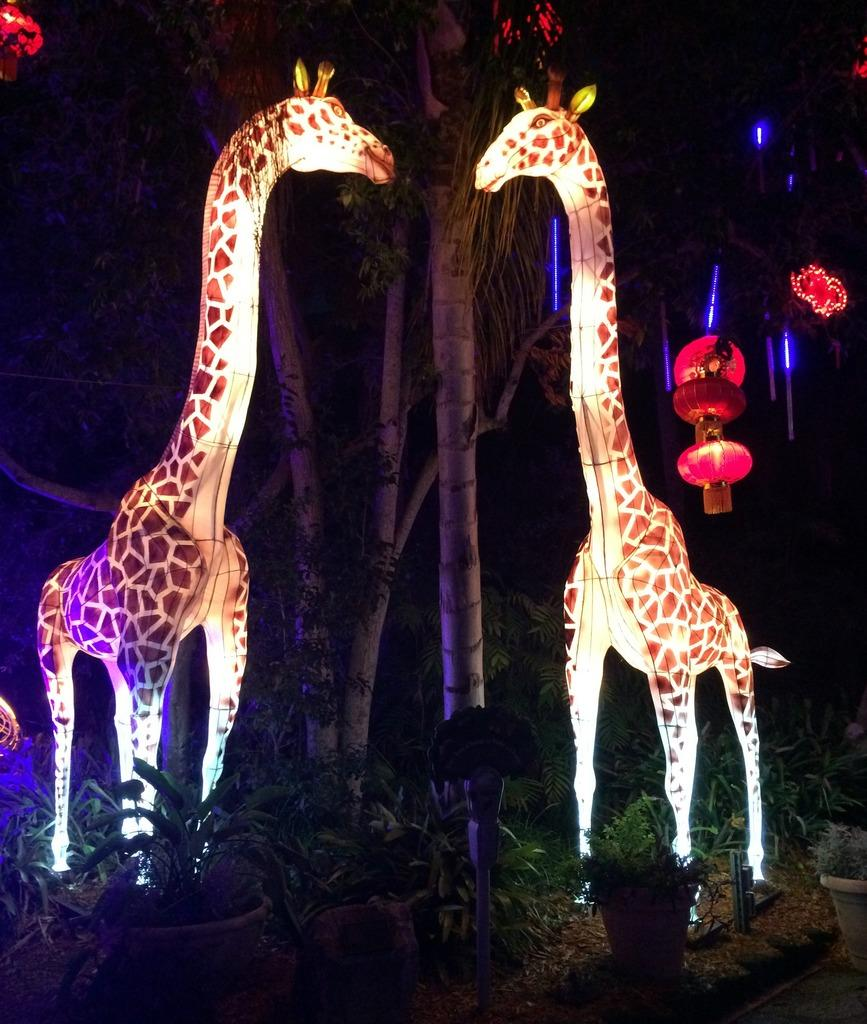What animals are depicted as statues in the image? There are statues of two giraffes in the image. What type of vegetation is present on the ground level in the image? There are plants on the ground in the image. What type of larger vegetation can be seen in the image? There are trees visible in the image. How would you describe the lighting conditions in the image? The background of the image is dark. What type of activity are the dinosaurs engaged in within the image? There are no dinosaurs present in the image, so it is not possible to answer that question. 